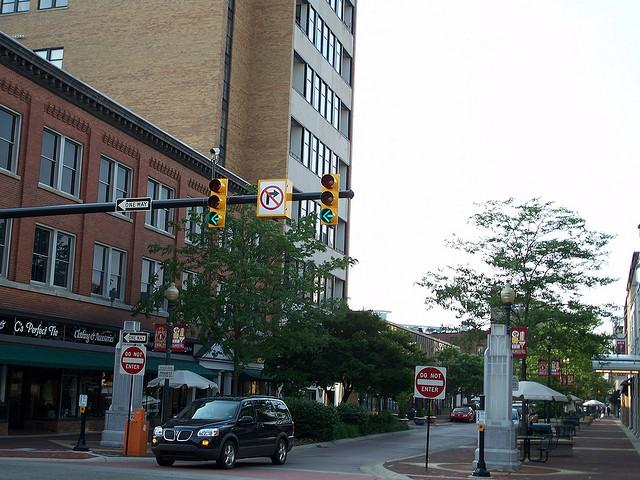Driving straight ahead might cause what? accident 